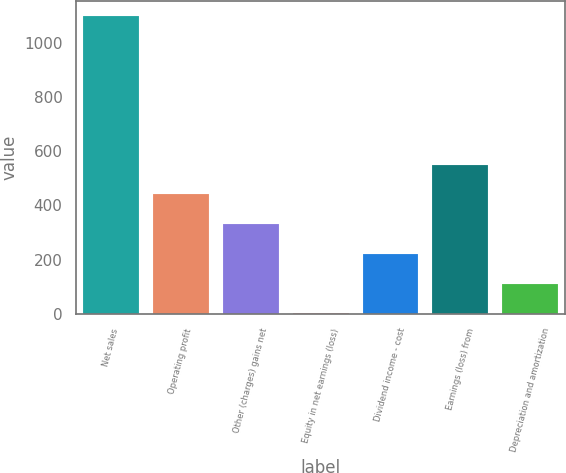Convert chart to OTSL. <chart><loc_0><loc_0><loc_500><loc_500><bar_chart><fcel>Net sales<fcel>Operating profit<fcel>Other (charges) gains net<fcel>Equity in net earnings (loss)<fcel>Dividend income - cost<fcel>Earnings (loss) from<fcel>Depreciation and amortization<nl><fcel>1098<fcel>440.4<fcel>330.8<fcel>2<fcel>221.2<fcel>550<fcel>111.6<nl></chart> 